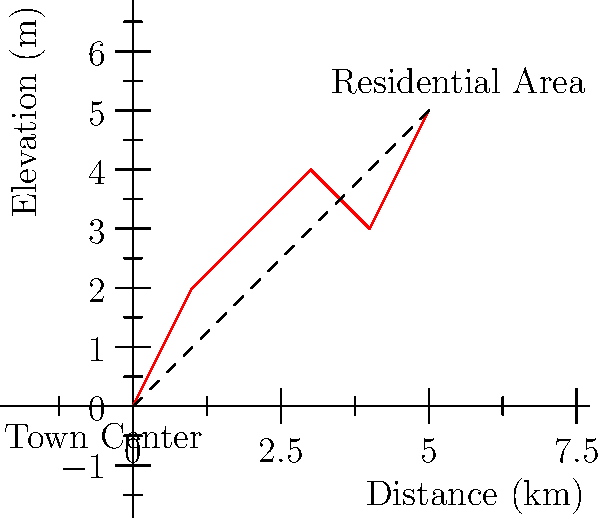As a holistic pediatrician integrating Eastern and Western approaches, you're consulted on a town planning committee for a new eco-friendly community. The civil engineer presents a water distribution system layout shown in the graph, where the red line represents the proposed pipeline route from the town center to a residential area. Given that water pressure decreases with elevation, what would you suggest to ensure consistent water pressure and promote sustainability? To approach this problem holistically, we need to consider both engineering principles and sustainable practices:

1. Analyze the elevation profile:
   The graph shows elevation increasing from 0m to 5m over a 5km distance.

2. Calculate the average slope:
   Slope = $\frac{\text{Rise}}{\text{Run}} = \frac{5\text{ m}}{5\text{ km}} = 1\text{ m/km}$ or 0.1%

3. Consider water pressure:
   Water pressure decreases by approximately 1 psi for every 2.31 feet (0.7 m) of elevation gain.

4. Evaluate pressure loss:
   Total elevation gain = 5 m
   Pressure loss ≈ $\frac{5\text{ m}}{0.7\text{ m/psi}} = 7.14\text{ psi}$

5. Assess need for pressure boosting:
   Given the gradual slope and moderate elevation gain, a single booster pump may be sufficient.

6. Integrate sustainable practices:
   - Use gravity-fed system where possible to reduce energy consumption
   - Implement rainwater harvesting and greywater recycling systems
   - Install pressure-reducing valves in downhill sections to prevent excessive pressure

7. Consider health implications:
   - Ensure proper water treatment to maintain quality throughout the system
   - Monitor for potential contaminants that may affect pediatric health

8. Holistic recommendation:
   Suggest a combination of a gravity-fed system with a strategically placed booster pump, complemented by rainwater harvesting and water recycling systems. This approach balances engineering needs with sustainability and health considerations.
Answer: Gravity-fed system with strategic booster pump, complemented by rainwater harvesting and recycling 